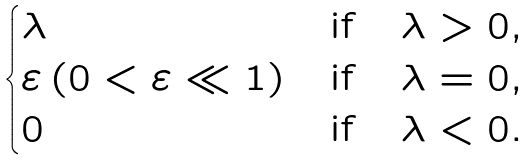Convert formula to latex. <formula><loc_0><loc_0><loc_500><loc_500>\begin{cases} \lambda & \text {if} \quad \lambda > 0 , \\ \varepsilon \, ( 0 < \varepsilon \ll 1 ) & \text {if} \quad \lambda = 0 , \\ 0 & \text {if} \quad \lambda < 0 . \end{cases}</formula> 